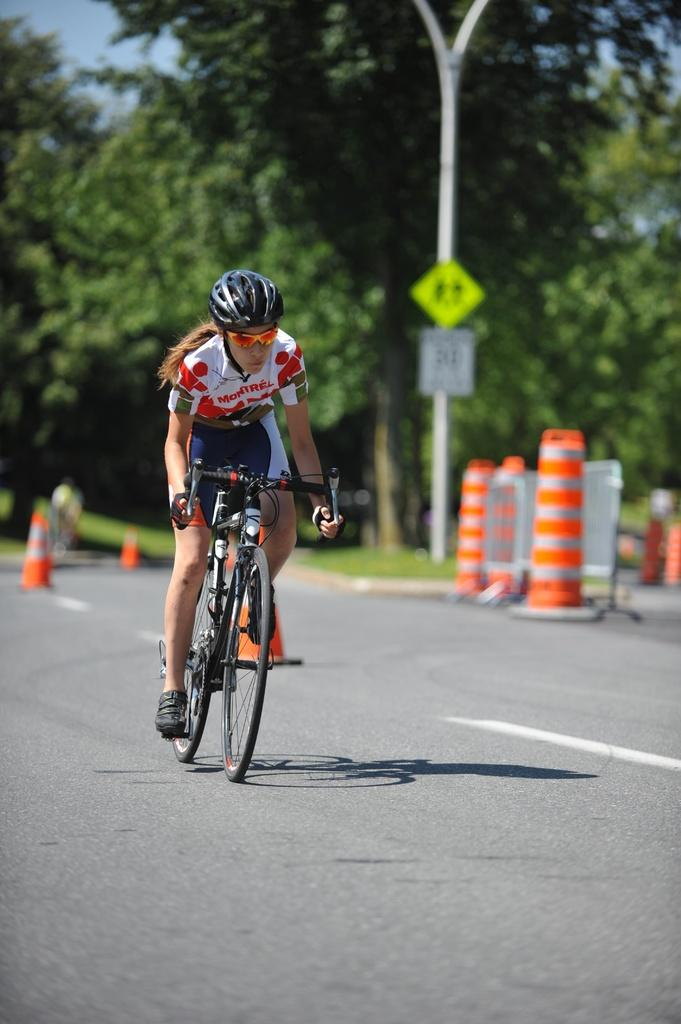Who is the main subject in the image? There is a woman in the image. What is the woman wearing on her head? The woman is wearing a helmet. What activity is the woman engaged in? The woman is riding a bicycle. What objects are present in the image related to traffic control? There are traffic cones in the image. What stationary object can be seen in the image? There is a pole in the image. What type of vegetation is visible in the image? There are trees in the image. What historical event is the woman commemorating in the image? There is no indication of a historical event in the image; the woman is simply riding a bicycle. How many rings can be seen on the woman's fingers in the image? There are no rings visible on the woman's fingers in the image. 